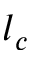<formula> <loc_0><loc_0><loc_500><loc_500>l _ { c }</formula> 